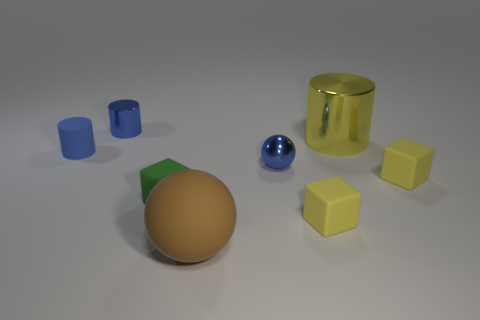Is the tiny ball made of the same material as the large thing that is in front of the matte cylinder?
Keep it short and to the point. No. How many things are cylinders that are behind the matte cylinder or tiny matte blocks to the left of the large brown rubber sphere?
Give a very brief answer. 3. How many other things are the same color as the metallic ball?
Ensure brevity in your answer.  2. Are there more yellow things behind the blue sphere than shiny cylinders in front of the big metallic object?
Offer a terse response. Yes. How many cubes are tiny yellow things or brown objects?
Ensure brevity in your answer.  2. How many things are balls to the right of the rubber ball or large blue rubber things?
Give a very brief answer. 1. The blue metallic thing that is on the right side of the small metal thing behind the tiny shiny object that is on the right side of the brown matte object is what shape?
Keep it short and to the point. Sphere. How many blue matte objects have the same shape as the brown object?
Your answer should be compact. 0. What material is the other tiny cylinder that is the same color as the rubber cylinder?
Keep it short and to the point. Metal. Do the tiny ball and the big cylinder have the same material?
Give a very brief answer. Yes. 